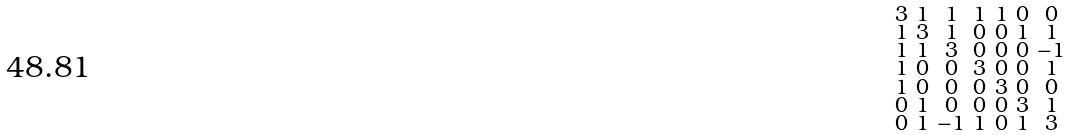<formula> <loc_0><loc_0><loc_500><loc_500>\begin{smallmatrix} 3 & 1 & 1 & 1 & 1 & 0 & 0 \\ 1 & 3 & 1 & 0 & 0 & 1 & 1 \\ 1 & 1 & 3 & 0 & 0 & 0 & - 1 \\ 1 & 0 & 0 & 3 & 0 & 0 & 1 \\ 1 & 0 & 0 & 0 & 3 & 0 & 0 \\ 0 & 1 & 0 & 0 & 0 & 3 & 1 \\ 0 & 1 & - 1 & 1 & 0 & 1 & 3 \end{smallmatrix}</formula> 